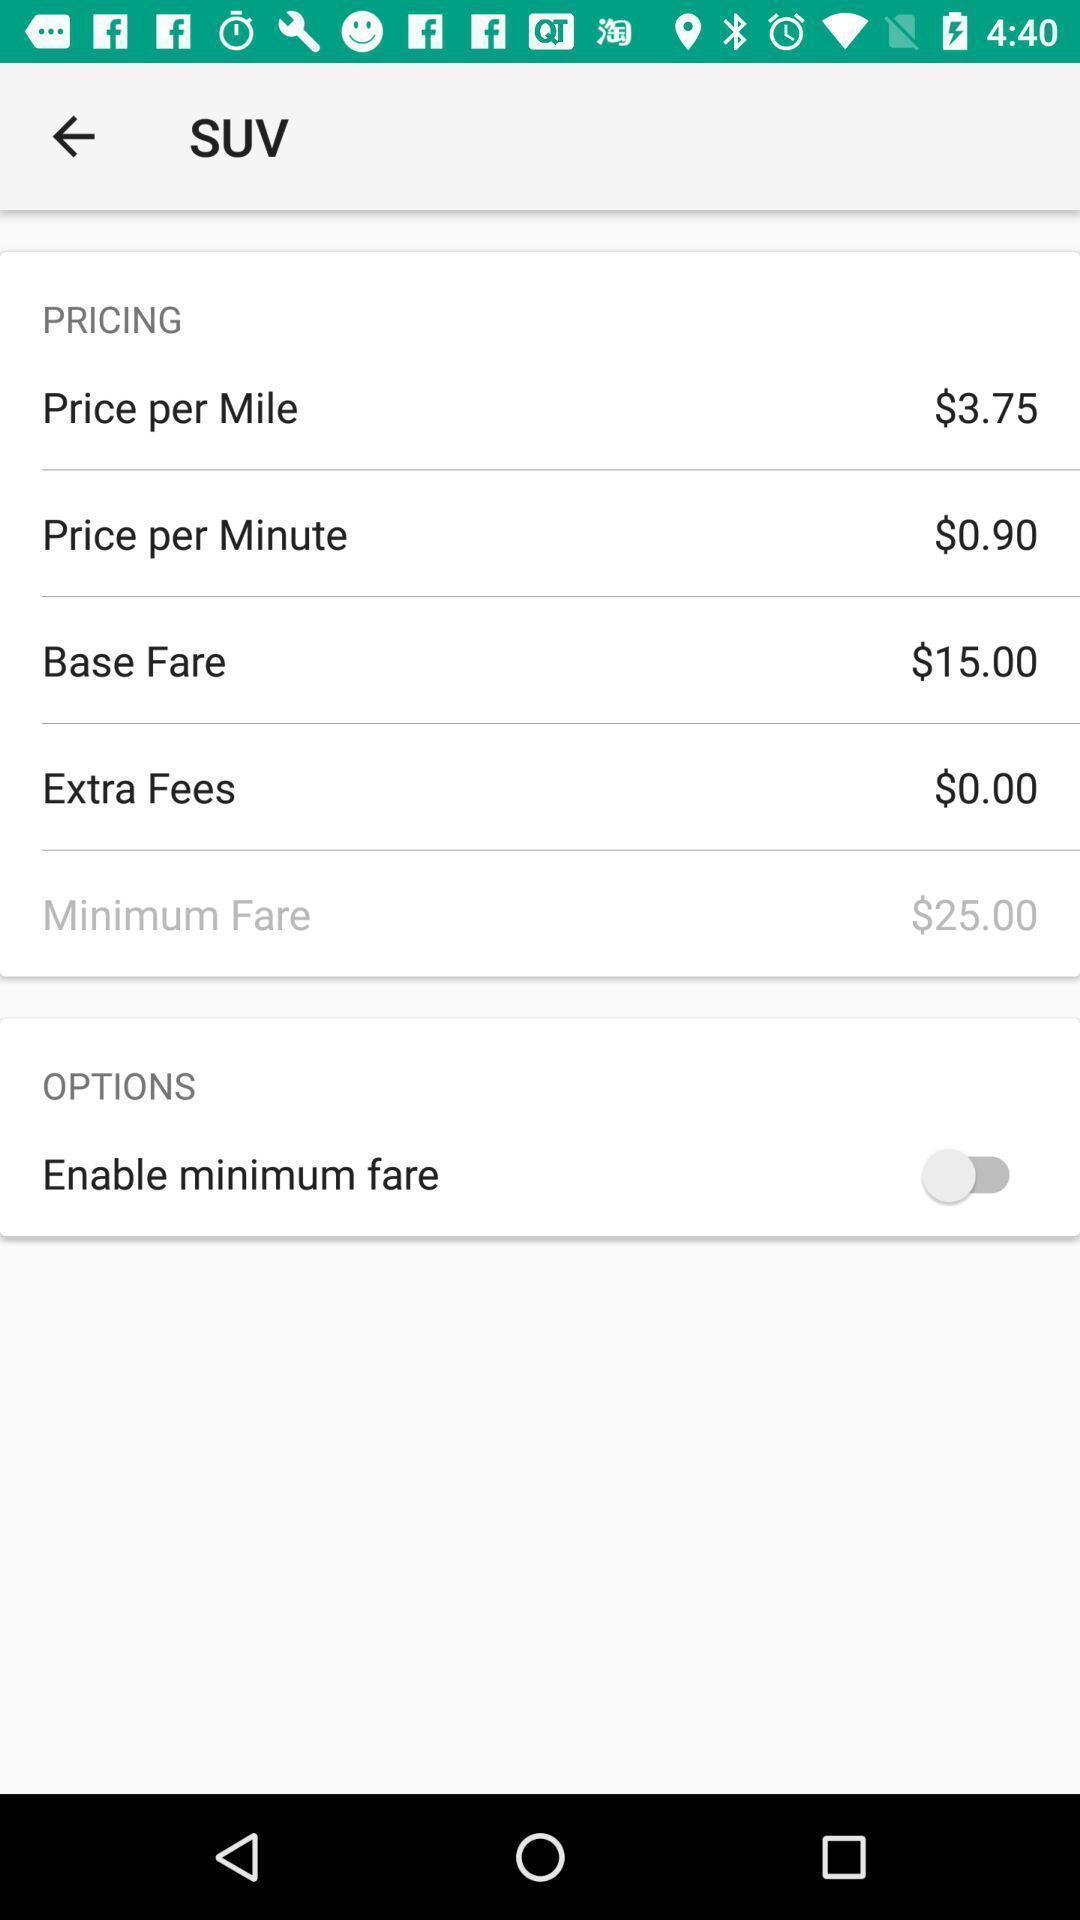Give me a summary of this screen capture. Screen showing list of options with prices. 